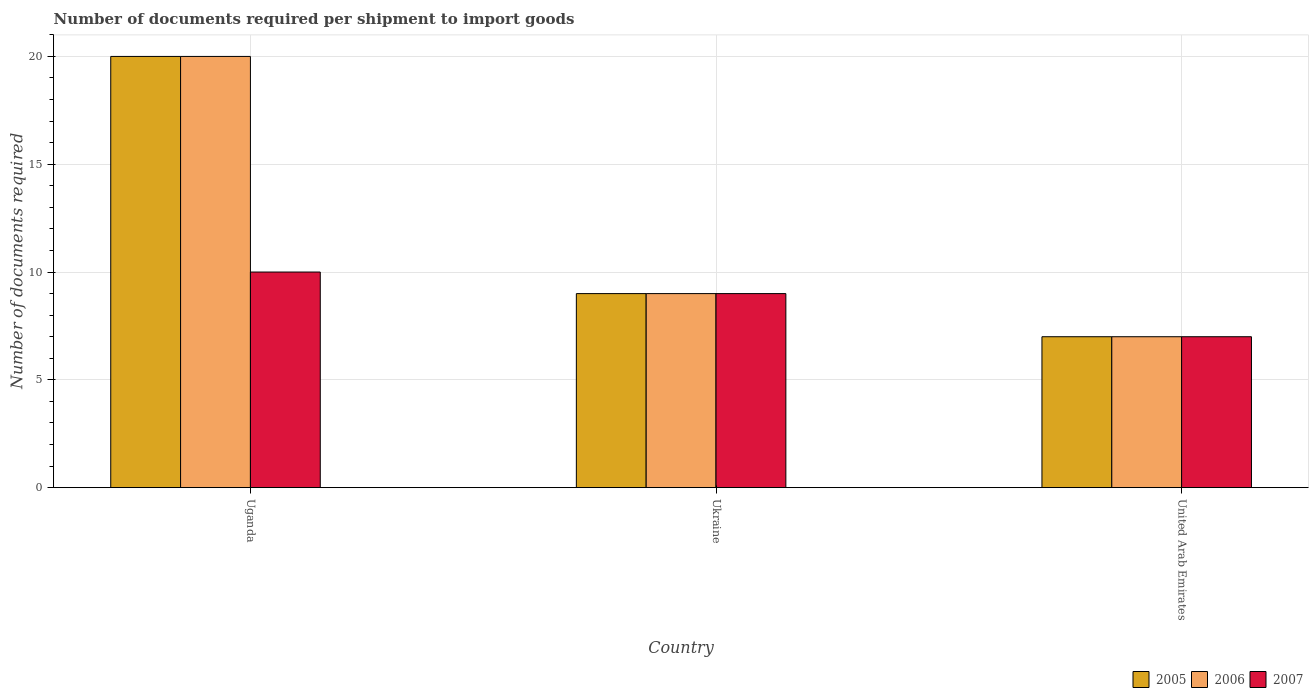How many different coloured bars are there?
Your answer should be very brief. 3. How many groups of bars are there?
Ensure brevity in your answer.  3. Are the number of bars on each tick of the X-axis equal?
Offer a very short reply. Yes. What is the label of the 3rd group of bars from the left?
Make the answer very short. United Arab Emirates. What is the number of documents required per shipment to import goods in 2006 in Uganda?
Your answer should be very brief. 20. In which country was the number of documents required per shipment to import goods in 2007 maximum?
Your answer should be very brief. Uganda. In which country was the number of documents required per shipment to import goods in 2006 minimum?
Make the answer very short. United Arab Emirates. What is the total number of documents required per shipment to import goods in 2007 in the graph?
Offer a very short reply. 26. What is the difference between the number of documents required per shipment to import goods in 2005 in United Arab Emirates and the number of documents required per shipment to import goods in 2006 in Ukraine?
Provide a short and direct response. -2. What is the average number of documents required per shipment to import goods in 2007 per country?
Make the answer very short. 8.67. What is the ratio of the number of documents required per shipment to import goods in 2007 in Uganda to that in United Arab Emirates?
Ensure brevity in your answer.  1.43. Is the difference between the number of documents required per shipment to import goods in 2007 in Uganda and Ukraine greater than the difference between the number of documents required per shipment to import goods in 2006 in Uganda and Ukraine?
Offer a very short reply. No. What is the difference between the highest and the second highest number of documents required per shipment to import goods in 2006?
Provide a succinct answer. -11. What does the 3rd bar from the right in Ukraine represents?
Keep it short and to the point. 2005. Is it the case that in every country, the sum of the number of documents required per shipment to import goods in 2005 and number of documents required per shipment to import goods in 2007 is greater than the number of documents required per shipment to import goods in 2006?
Keep it short and to the point. Yes. How many bars are there?
Your response must be concise. 9. Are all the bars in the graph horizontal?
Your answer should be compact. No. Are the values on the major ticks of Y-axis written in scientific E-notation?
Your answer should be compact. No. Does the graph contain any zero values?
Your answer should be very brief. No. Does the graph contain grids?
Keep it short and to the point. Yes. Where does the legend appear in the graph?
Your answer should be very brief. Bottom right. How many legend labels are there?
Make the answer very short. 3. How are the legend labels stacked?
Your answer should be compact. Horizontal. What is the title of the graph?
Your response must be concise. Number of documents required per shipment to import goods. What is the label or title of the Y-axis?
Offer a terse response. Number of documents required. What is the Number of documents required of 2006 in Uganda?
Ensure brevity in your answer.  20. What is the Number of documents required of 2007 in Uganda?
Ensure brevity in your answer.  10. What is the Number of documents required in 2005 in Ukraine?
Ensure brevity in your answer.  9. What is the Number of documents required in 2006 in Ukraine?
Give a very brief answer. 9. What is the Number of documents required in 2007 in Ukraine?
Keep it short and to the point. 9. What is the Number of documents required in 2005 in United Arab Emirates?
Keep it short and to the point. 7. What is the Number of documents required of 2007 in United Arab Emirates?
Provide a succinct answer. 7. Across all countries, what is the minimum Number of documents required in 2005?
Provide a succinct answer. 7. Across all countries, what is the minimum Number of documents required in 2007?
Your answer should be compact. 7. What is the total Number of documents required of 2005 in the graph?
Make the answer very short. 36. What is the total Number of documents required in 2006 in the graph?
Provide a short and direct response. 36. What is the difference between the Number of documents required in 2005 in Uganda and that in Ukraine?
Offer a very short reply. 11. What is the difference between the Number of documents required of 2006 in Uganda and that in Ukraine?
Your answer should be very brief. 11. What is the difference between the Number of documents required of 2007 in Uganda and that in Ukraine?
Provide a short and direct response. 1. What is the difference between the Number of documents required in 2006 in Uganda and that in United Arab Emirates?
Provide a succinct answer. 13. What is the difference between the Number of documents required of 2007 in Uganda and that in United Arab Emirates?
Your response must be concise. 3. What is the difference between the Number of documents required in 2006 in Ukraine and that in United Arab Emirates?
Offer a very short reply. 2. What is the difference between the Number of documents required of 2007 in Ukraine and that in United Arab Emirates?
Make the answer very short. 2. What is the difference between the Number of documents required of 2005 in Uganda and the Number of documents required of 2006 in United Arab Emirates?
Your answer should be very brief. 13. What is the difference between the Number of documents required of 2005 in Uganda and the Number of documents required of 2007 in United Arab Emirates?
Offer a very short reply. 13. What is the difference between the Number of documents required in 2006 in Uganda and the Number of documents required in 2007 in United Arab Emirates?
Your answer should be very brief. 13. What is the difference between the Number of documents required of 2005 in Ukraine and the Number of documents required of 2006 in United Arab Emirates?
Ensure brevity in your answer.  2. What is the difference between the Number of documents required of 2005 in Ukraine and the Number of documents required of 2007 in United Arab Emirates?
Provide a short and direct response. 2. What is the difference between the Number of documents required in 2006 in Ukraine and the Number of documents required in 2007 in United Arab Emirates?
Make the answer very short. 2. What is the average Number of documents required of 2007 per country?
Your response must be concise. 8.67. What is the difference between the Number of documents required of 2005 and Number of documents required of 2006 in Uganda?
Provide a succinct answer. 0. What is the difference between the Number of documents required in 2005 and Number of documents required in 2006 in Ukraine?
Ensure brevity in your answer.  0. What is the difference between the Number of documents required in 2005 and Number of documents required in 2007 in Ukraine?
Ensure brevity in your answer.  0. What is the difference between the Number of documents required in 2006 and Number of documents required in 2007 in Ukraine?
Offer a terse response. 0. What is the difference between the Number of documents required in 2005 and Number of documents required in 2006 in United Arab Emirates?
Provide a succinct answer. 0. What is the difference between the Number of documents required of 2005 and Number of documents required of 2007 in United Arab Emirates?
Your answer should be compact. 0. What is the ratio of the Number of documents required of 2005 in Uganda to that in Ukraine?
Give a very brief answer. 2.22. What is the ratio of the Number of documents required in 2006 in Uganda to that in Ukraine?
Make the answer very short. 2.22. What is the ratio of the Number of documents required of 2007 in Uganda to that in Ukraine?
Offer a very short reply. 1.11. What is the ratio of the Number of documents required of 2005 in Uganda to that in United Arab Emirates?
Ensure brevity in your answer.  2.86. What is the ratio of the Number of documents required in 2006 in Uganda to that in United Arab Emirates?
Ensure brevity in your answer.  2.86. What is the ratio of the Number of documents required in 2007 in Uganda to that in United Arab Emirates?
Your answer should be very brief. 1.43. What is the ratio of the Number of documents required in 2006 in Ukraine to that in United Arab Emirates?
Provide a succinct answer. 1.29. What is the ratio of the Number of documents required of 2007 in Ukraine to that in United Arab Emirates?
Keep it short and to the point. 1.29. What is the difference between the highest and the second highest Number of documents required in 2005?
Your answer should be compact. 11. What is the difference between the highest and the second highest Number of documents required of 2006?
Give a very brief answer. 11. What is the difference between the highest and the lowest Number of documents required in 2006?
Give a very brief answer. 13. 